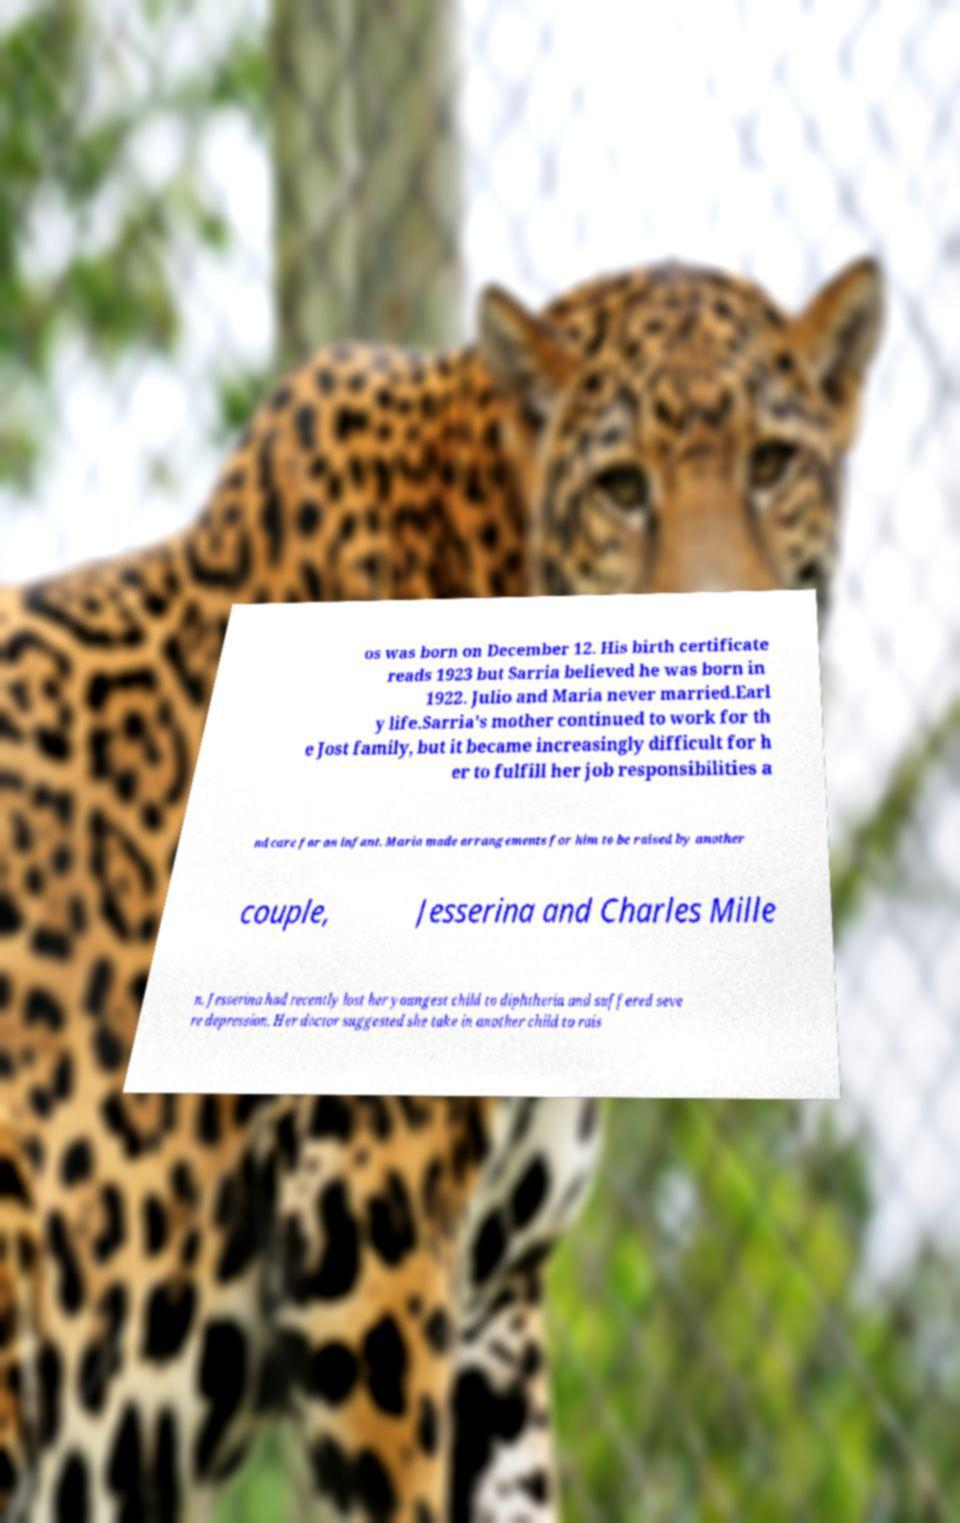What messages or text are displayed in this image? I need them in a readable, typed format. os was born on December 12. His birth certificate reads 1923 but Sarria believed he was born in 1922. Julio and Maria never married.Earl y life.Sarria's mother continued to work for th e Jost family, but it became increasingly difficult for h er to fulfill her job responsibilities a nd care for an infant. Maria made arrangements for him to be raised by another couple, Jesserina and Charles Mille n. Jesserina had recently lost her youngest child to diphtheria and suffered seve re depression. Her doctor suggested she take in another child to rais 